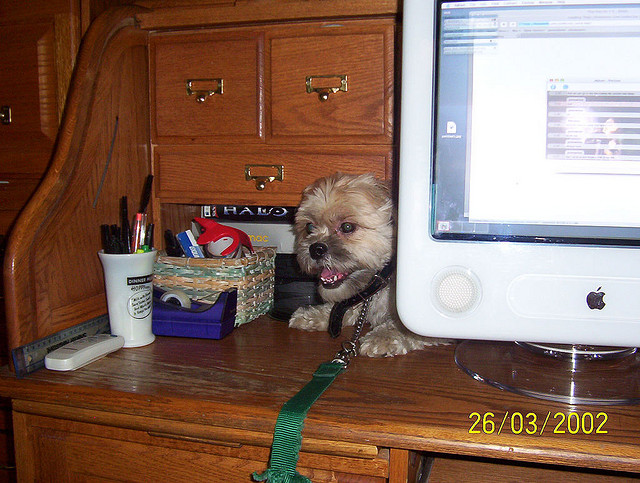Please transcribe the text in this image. HAWE 26 03 2002 